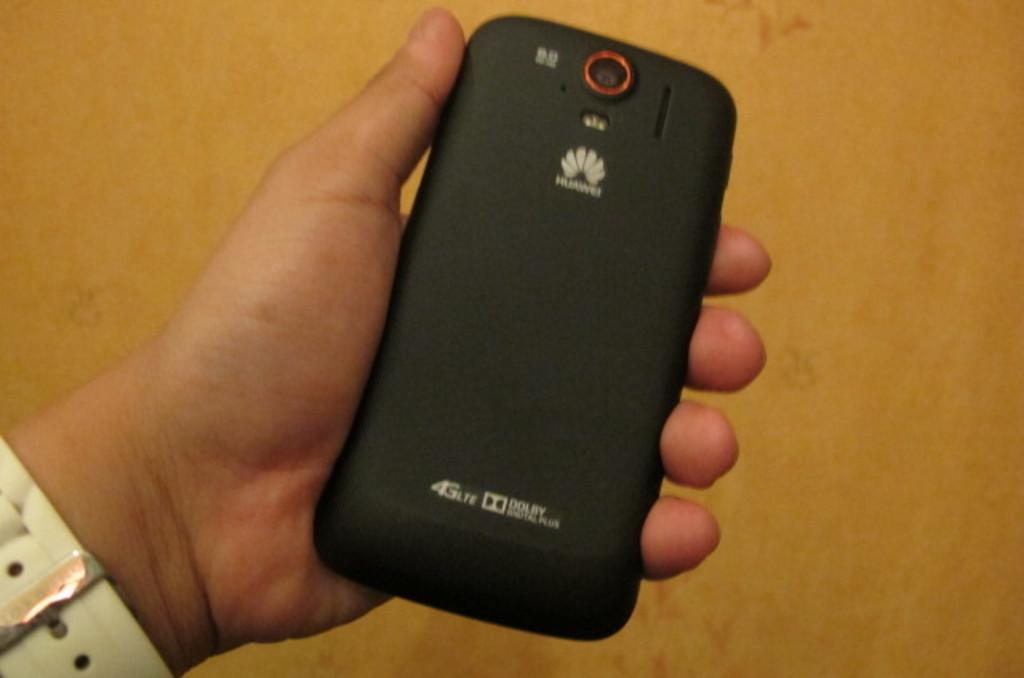Provide a one-sentence caption for the provided image. A phone that has 4G lite and Dolby ability is being held by a person. 